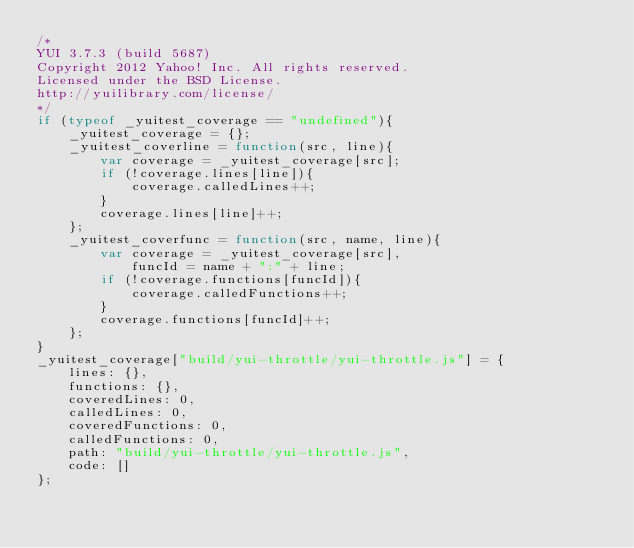Convert code to text. <code><loc_0><loc_0><loc_500><loc_500><_JavaScript_>/*
YUI 3.7.3 (build 5687)
Copyright 2012 Yahoo! Inc. All rights reserved.
Licensed under the BSD License.
http://yuilibrary.com/license/
*/
if (typeof _yuitest_coverage == "undefined"){
    _yuitest_coverage = {};
    _yuitest_coverline = function(src, line){
        var coverage = _yuitest_coverage[src];
        if (!coverage.lines[line]){
            coverage.calledLines++;
        }
        coverage.lines[line]++;
    };
    _yuitest_coverfunc = function(src, name, line){
        var coverage = _yuitest_coverage[src],
            funcId = name + ":" + line;
        if (!coverage.functions[funcId]){
            coverage.calledFunctions++;
        }
        coverage.functions[funcId]++;
    };
}
_yuitest_coverage["build/yui-throttle/yui-throttle.js"] = {
    lines: {},
    functions: {},
    coveredLines: 0,
    calledLines: 0,
    coveredFunctions: 0,
    calledFunctions: 0,
    path: "build/yui-throttle/yui-throttle.js",
    code: []
};</code> 